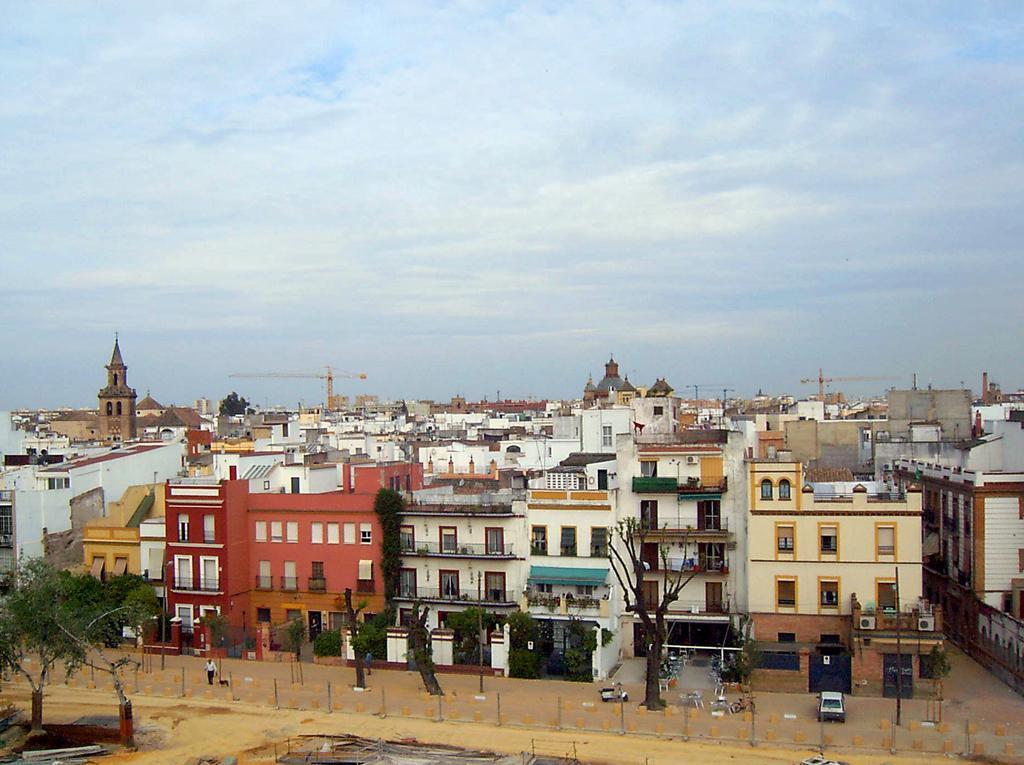How would you summarize this image in a sentence or two? In this image, there are a few buildings and vehicles. We can see some people. We can see some trees and poles. We can see the ground with some objects. We can see some cranes and the sky with clouds. 